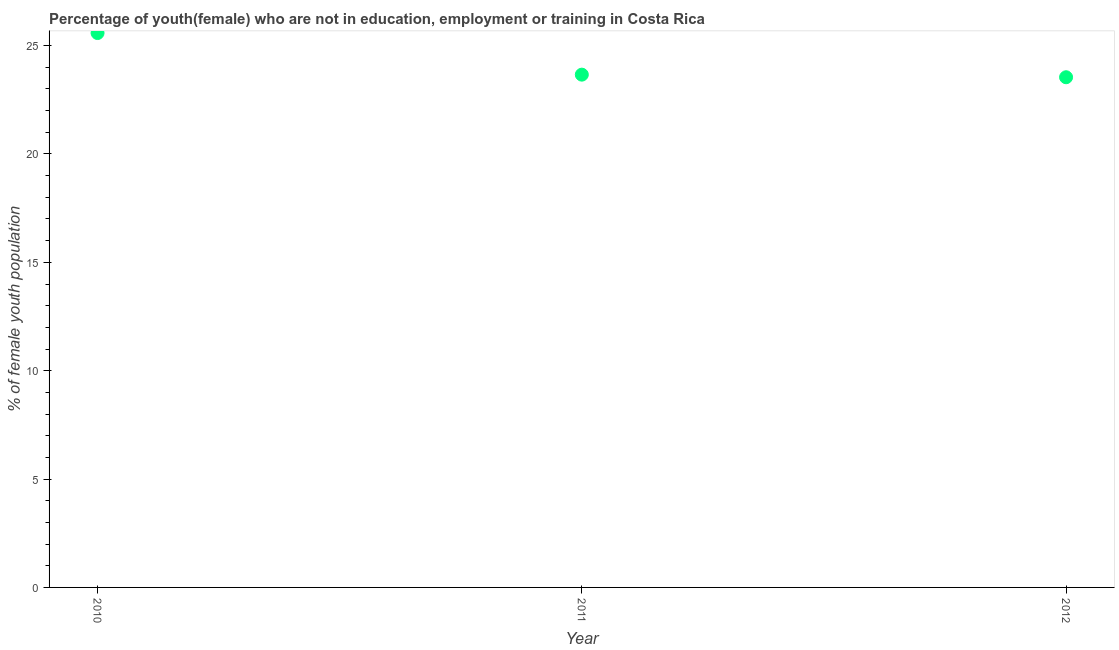What is the unemployed female youth population in 2012?
Offer a terse response. 23.54. Across all years, what is the maximum unemployed female youth population?
Provide a short and direct response. 25.58. Across all years, what is the minimum unemployed female youth population?
Provide a succinct answer. 23.54. In which year was the unemployed female youth population minimum?
Your response must be concise. 2012. What is the sum of the unemployed female youth population?
Keep it short and to the point. 72.78. What is the difference between the unemployed female youth population in 2010 and 2012?
Your response must be concise. 2.04. What is the average unemployed female youth population per year?
Your answer should be compact. 24.26. What is the median unemployed female youth population?
Your answer should be very brief. 23.66. In how many years, is the unemployed female youth population greater than 5 %?
Your answer should be compact. 3. What is the ratio of the unemployed female youth population in 2011 to that in 2012?
Keep it short and to the point. 1.01. Is the unemployed female youth population in 2010 less than that in 2012?
Your response must be concise. No. Is the difference between the unemployed female youth population in 2010 and 2011 greater than the difference between any two years?
Your answer should be very brief. No. What is the difference between the highest and the second highest unemployed female youth population?
Keep it short and to the point. 1.92. What is the difference between the highest and the lowest unemployed female youth population?
Give a very brief answer. 2.04. In how many years, is the unemployed female youth population greater than the average unemployed female youth population taken over all years?
Keep it short and to the point. 1. How many years are there in the graph?
Offer a very short reply. 3. What is the difference between two consecutive major ticks on the Y-axis?
Ensure brevity in your answer.  5. What is the title of the graph?
Your answer should be very brief. Percentage of youth(female) who are not in education, employment or training in Costa Rica. What is the label or title of the Y-axis?
Your response must be concise. % of female youth population. What is the % of female youth population in 2010?
Provide a succinct answer. 25.58. What is the % of female youth population in 2011?
Offer a very short reply. 23.66. What is the % of female youth population in 2012?
Give a very brief answer. 23.54. What is the difference between the % of female youth population in 2010 and 2011?
Offer a very short reply. 1.92. What is the difference between the % of female youth population in 2010 and 2012?
Offer a terse response. 2.04. What is the difference between the % of female youth population in 2011 and 2012?
Provide a succinct answer. 0.12. What is the ratio of the % of female youth population in 2010 to that in 2011?
Your response must be concise. 1.08. What is the ratio of the % of female youth population in 2010 to that in 2012?
Offer a terse response. 1.09. 